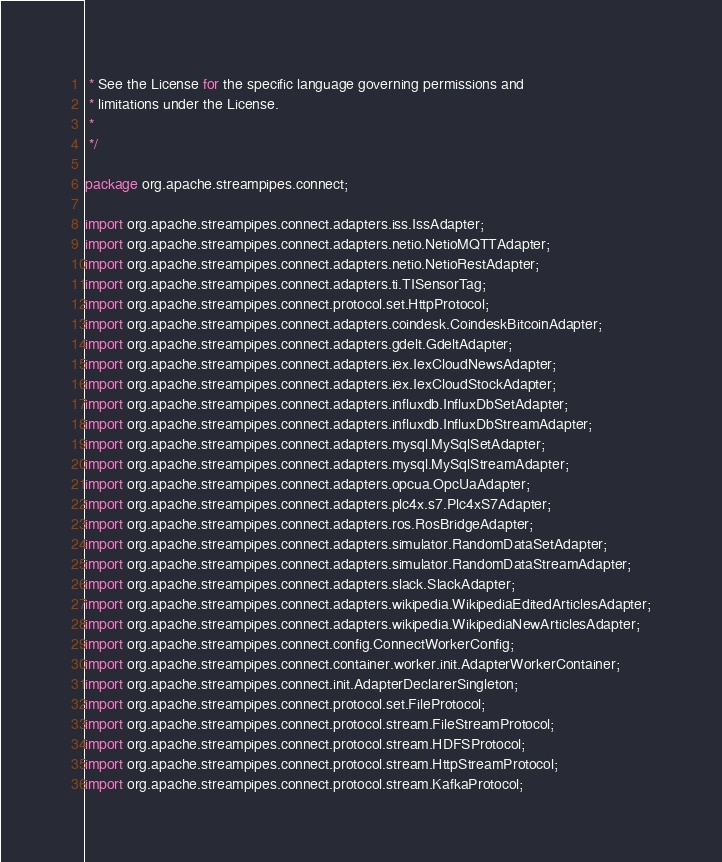<code> <loc_0><loc_0><loc_500><loc_500><_Java_> * See the License for the specific language governing permissions and
 * limitations under the License.
 *
 */

package org.apache.streampipes.connect;

import org.apache.streampipes.connect.adapters.iss.IssAdapter;
import org.apache.streampipes.connect.adapters.netio.NetioMQTTAdapter;
import org.apache.streampipes.connect.adapters.netio.NetioRestAdapter;
import org.apache.streampipes.connect.adapters.ti.TISensorTag;
import org.apache.streampipes.connect.protocol.set.HttpProtocol;
import org.apache.streampipes.connect.adapters.coindesk.CoindeskBitcoinAdapter;
import org.apache.streampipes.connect.adapters.gdelt.GdeltAdapter;
import org.apache.streampipes.connect.adapters.iex.IexCloudNewsAdapter;
import org.apache.streampipes.connect.adapters.iex.IexCloudStockAdapter;
import org.apache.streampipes.connect.adapters.influxdb.InfluxDbSetAdapter;
import org.apache.streampipes.connect.adapters.influxdb.InfluxDbStreamAdapter;
import org.apache.streampipes.connect.adapters.mysql.MySqlSetAdapter;
import org.apache.streampipes.connect.adapters.mysql.MySqlStreamAdapter;
import org.apache.streampipes.connect.adapters.opcua.OpcUaAdapter;
import org.apache.streampipes.connect.adapters.plc4x.s7.Plc4xS7Adapter;
import org.apache.streampipes.connect.adapters.ros.RosBridgeAdapter;
import org.apache.streampipes.connect.adapters.simulator.RandomDataSetAdapter;
import org.apache.streampipes.connect.adapters.simulator.RandomDataStreamAdapter;
import org.apache.streampipes.connect.adapters.slack.SlackAdapter;
import org.apache.streampipes.connect.adapters.wikipedia.WikipediaEditedArticlesAdapter;
import org.apache.streampipes.connect.adapters.wikipedia.WikipediaNewArticlesAdapter;
import org.apache.streampipes.connect.config.ConnectWorkerConfig;
import org.apache.streampipes.connect.container.worker.init.AdapterWorkerContainer;
import org.apache.streampipes.connect.init.AdapterDeclarerSingleton;
import org.apache.streampipes.connect.protocol.set.FileProtocol;
import org.apache.streampipes.connect.protocol.stream.FileStreamProtocol;
import org.apache.streampipes.connect.protocol.stream.HDFSProtocol;
import org.apache.streampipes.connect.protocol.stream.HttpStreamProtocol;
import org.apache.streampipes.connect.protocol.stream.KafkaProtocol;</code> 